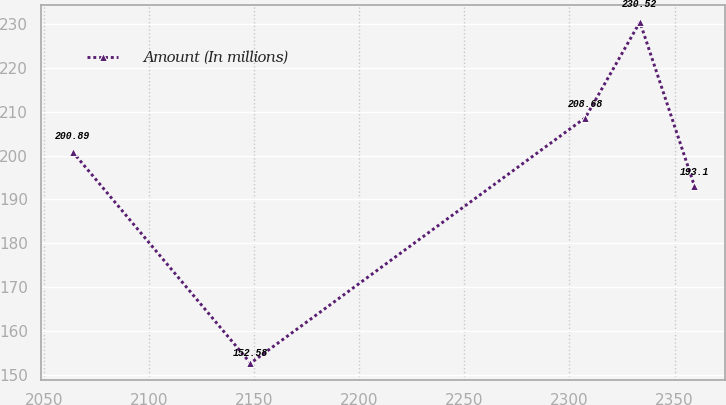Convert chart. <chart><loc_0><loc_0><loc_500><loc_500><line_chart><ecel><fcel>Amount (In millions)<nl><fcel>2063.62<fcel>200.89<nl><fcel>2148.27<fcel>152.58<nl><fcel>2307.62<fcel>208.68<nl><fcel>2333.54<fcel>230.52<nl><fcel>2359.46<fcel>193.1<nl></chart> 